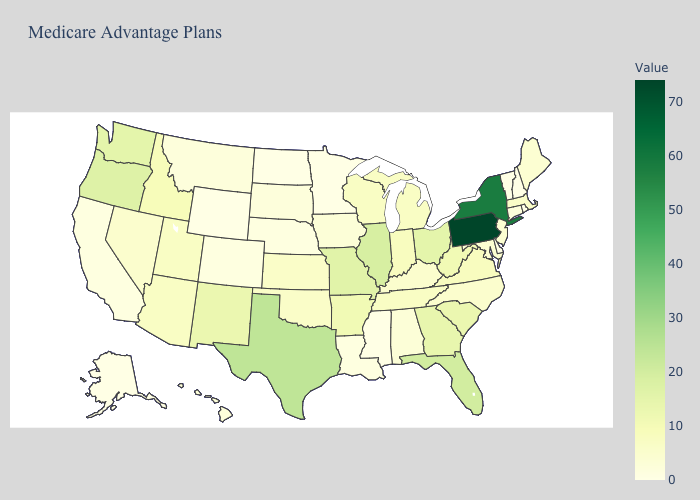Which states have the lowest value in the Northeast?
Keep it brief. New Hampshire, Rhode Island, Vermont. Does West Virginia have the highest value in the South?
Write a very short answer. No. Among the states that border West Virginia , does Pennsylvania have the highest value?
Be succinct. Yes. 